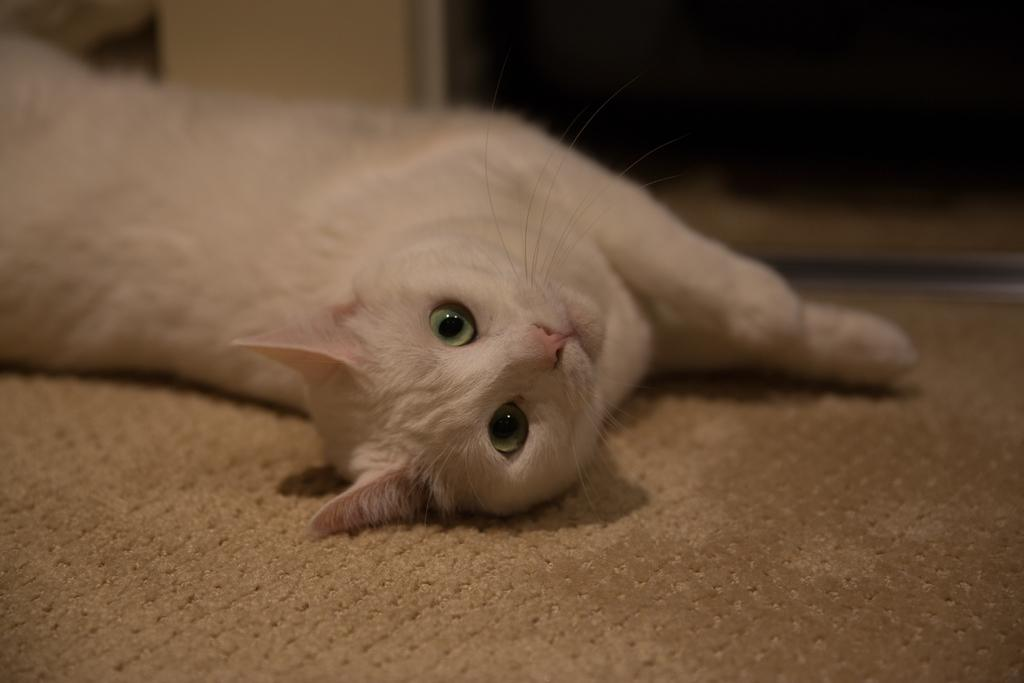What animal is present in the image? There is a cat in the image. What is the cat lying on? The cat is lying on a mat. Where is the cat positioned in the image? The cat is in the center of the image. What is the title of the book the cat is reading in the image? There is no book present in the image, and therefore no title to mention. 